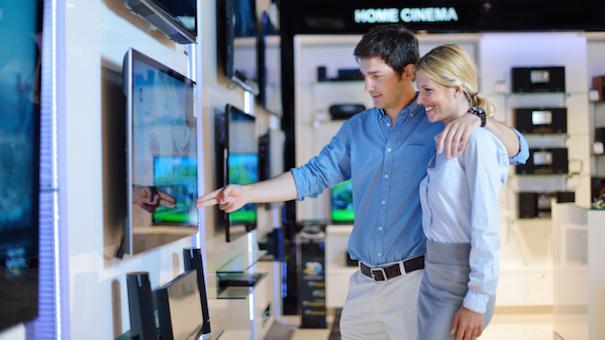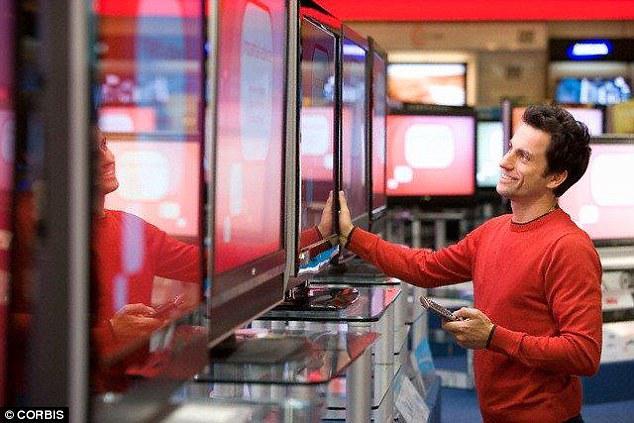The first image is the image on the left, the second image is the image on the right. Given the left and right images, does the statement "In one image, a man and woman are standing together looking at a display television, the man's arm stretched out pointing at the screen." hold true? Answer yes or no. Yes. The first image is the image on the left, the second image is the image on the right. Given the left and right images, does the statement "At least one of the images shows a man with his arm around a woman's shoulder." hold true? Answer yes or no. Yes. 